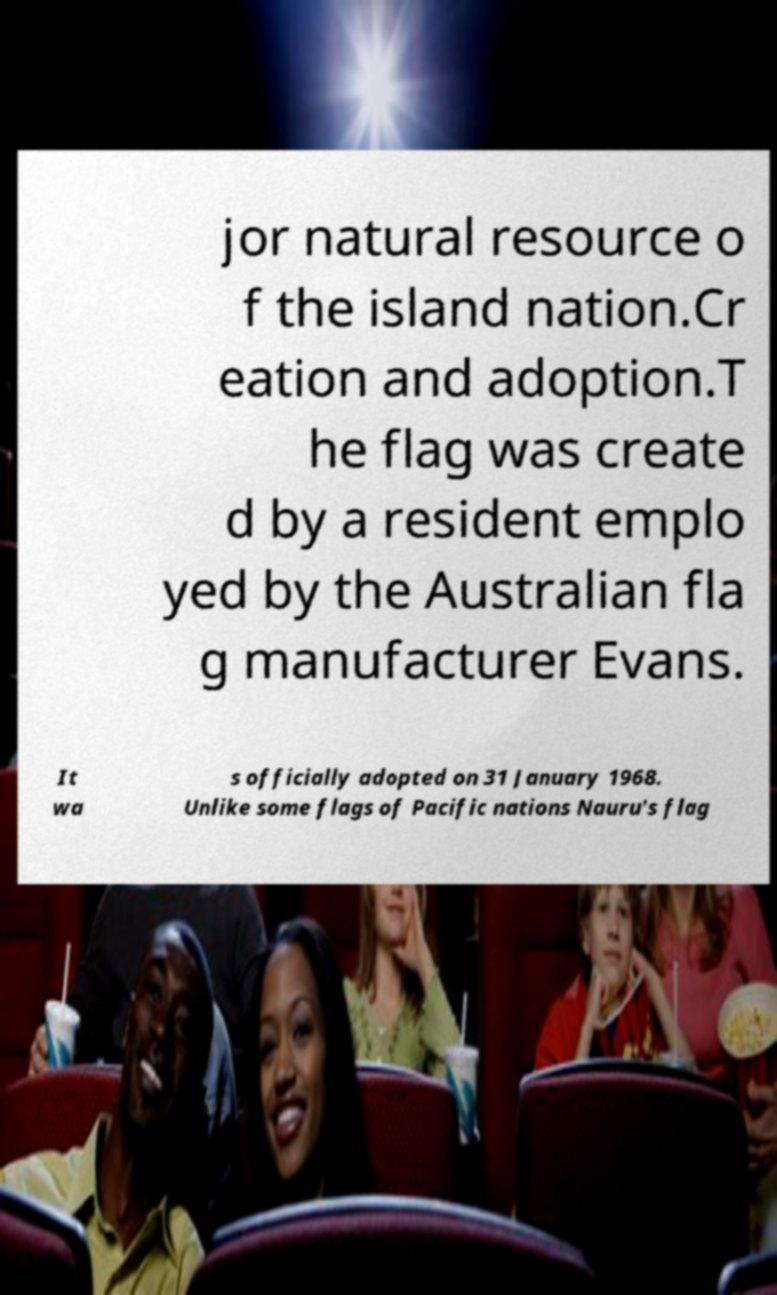Please identify and transcribe the text found in this image. jor natural resource o f the island nation.Cr eation and adoption.T he flag was create d by a resident emplo yed by the Australian fla g manufacturer Evans. It wa s officially adopted on 31 January 1968. Unlike some flags of Pacific nations Nauru's flag 